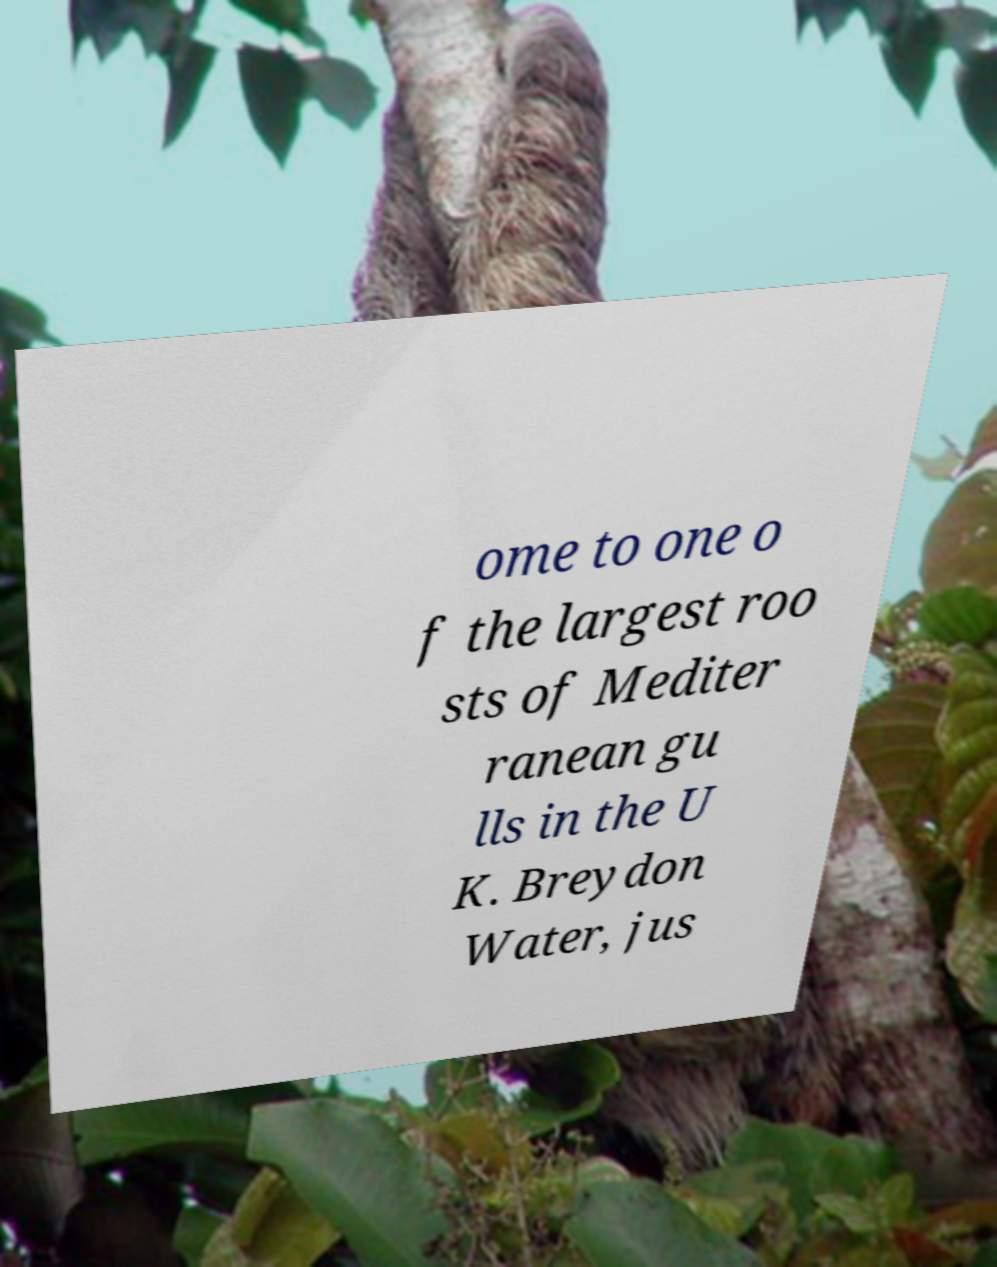Can you read and provide the text displayed in the image?This photo seems to have some interesting text. Can you extract and type it out for me? ome to one o f the largest roo sts of Mediter ranean gu lls in the U K. Breydon Water, jus 